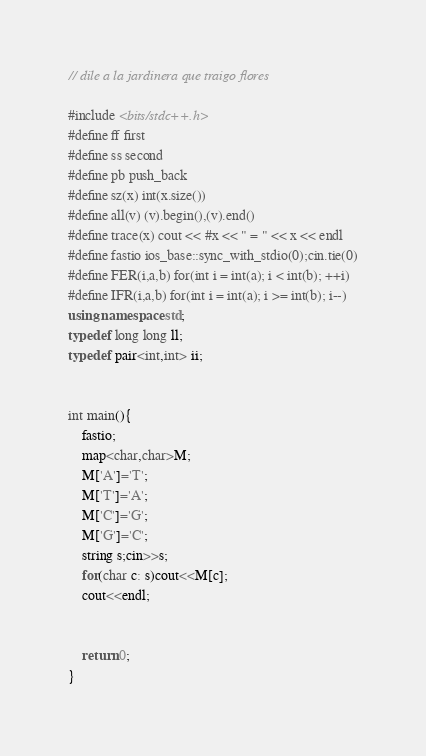Convert code to text. <code><loc_0><loc_0><loc_500><loc_500><_C++_>// dile a la jardinera que traigo flores

#include <bits/stdc++.h>
#define ff first
#define ss second
#define pb push_back
#define sz(x) int(x.size())
#define all(v) (v).begin(),(v).end()
#define trace(x) cout << #x << " = " << x << endl
#define fastio ios_base::sync_with_stdio(0);cin.tie(0)
#define FER(i,a,b) for(int i = int(a); i < int(b); ++i)
#define IFR(i,a,b) for(int i = int(a); i >= int(b); i--)
using namespace std;
typedef long long ll;
typedef pair<int,int> ii;


int main(){	
	fastio;
	map<char,char>M;
	M['A']='T';
	M['T']='A';
	M['C']='G';
	M['G']='C';
	string s;cin>>s;
	for(char c: s)cout<<M[c];
	cout<<endl;


	return 0;
}
</code> 